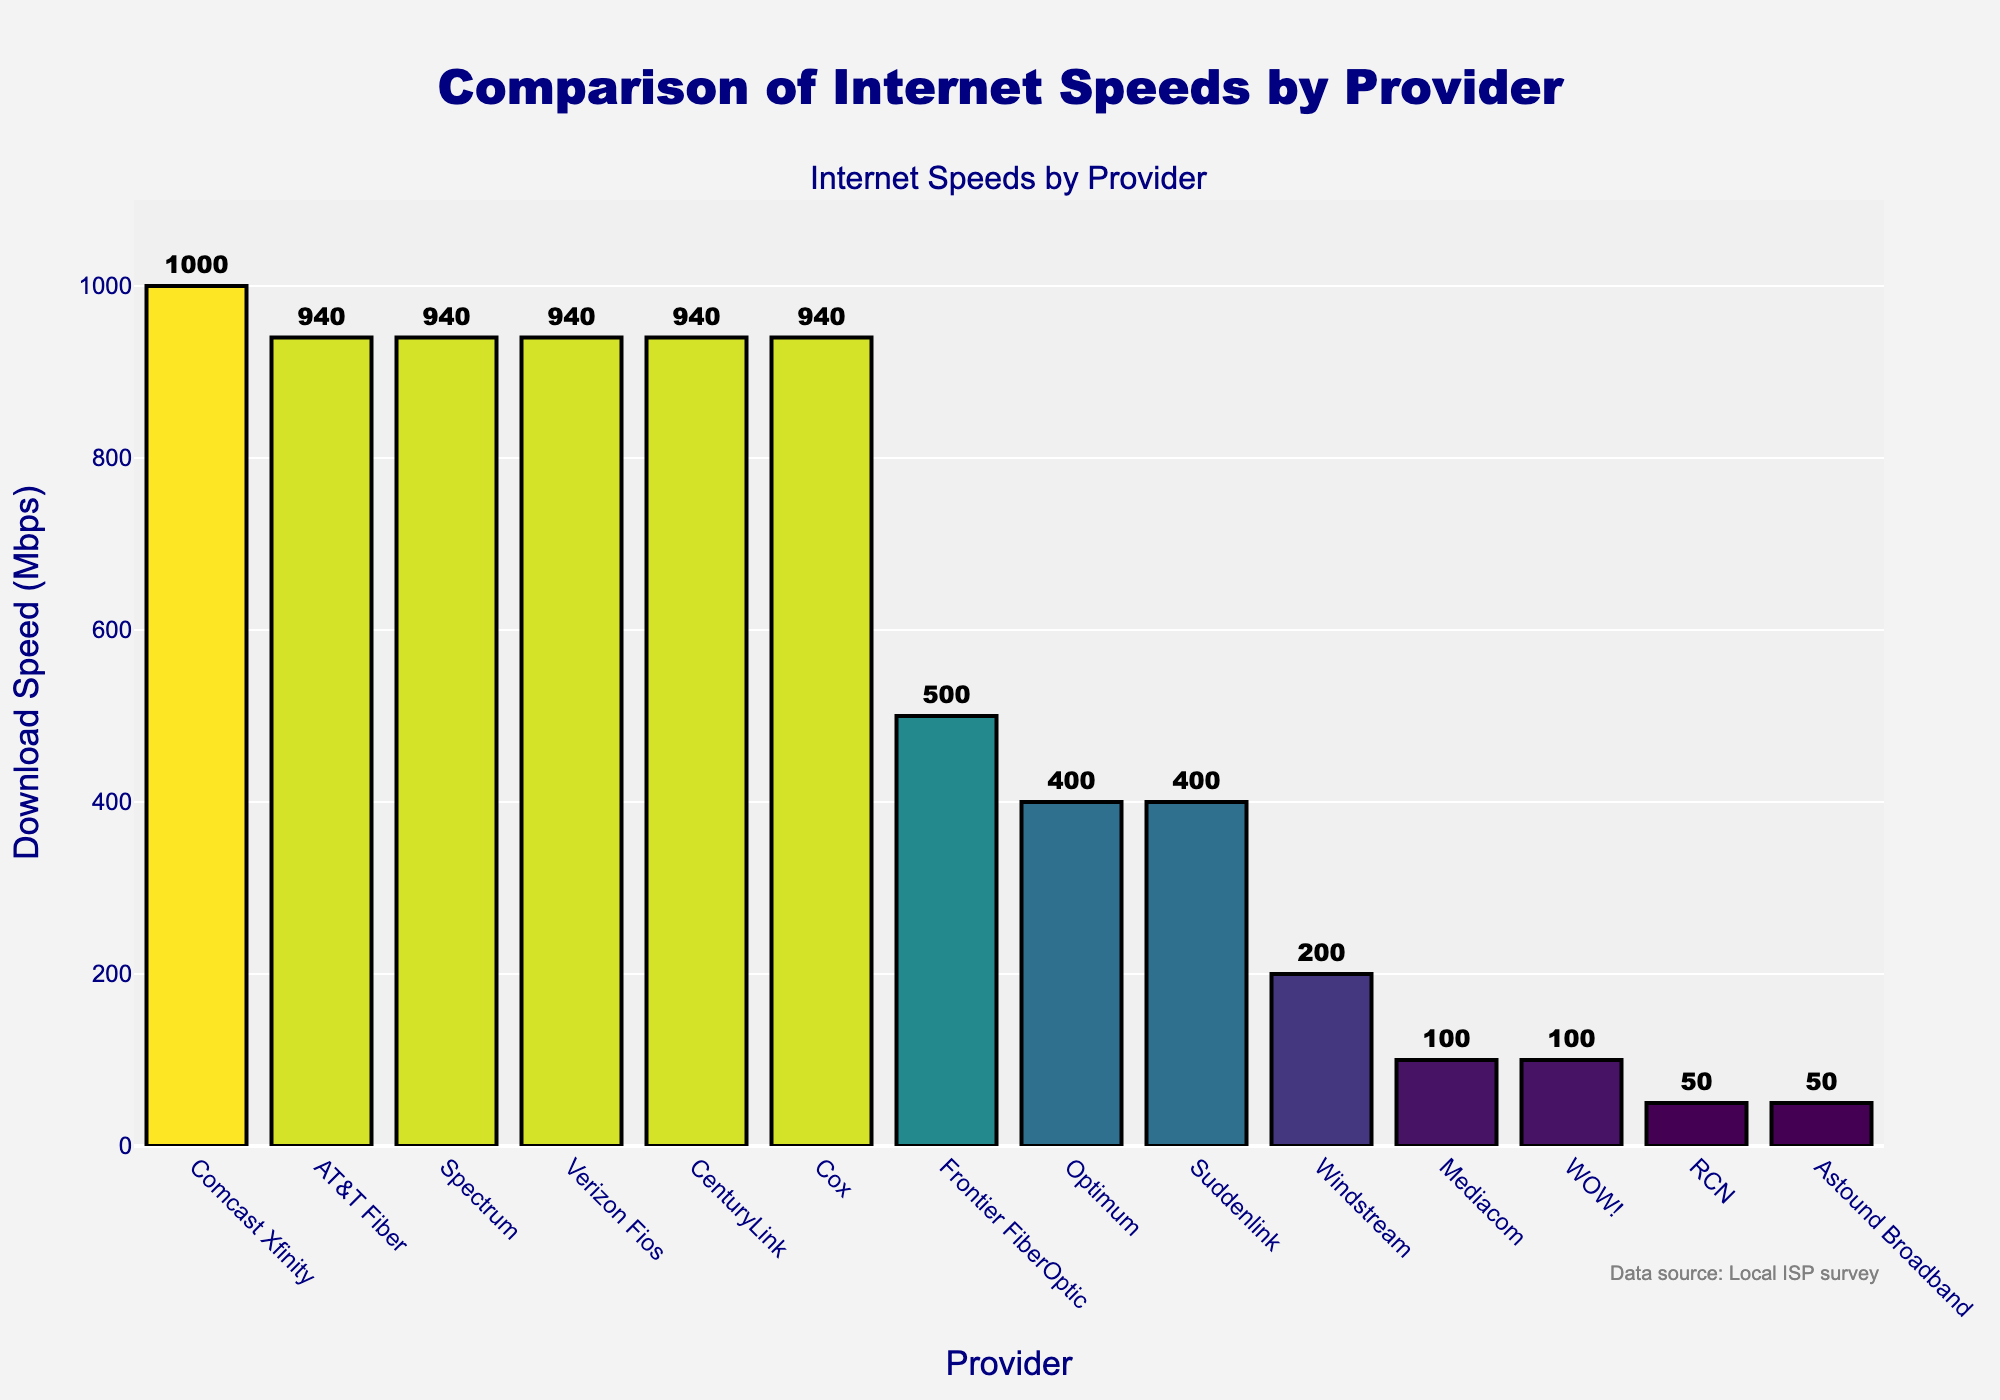What is the maximum download speed offered by any provider? The highest bar represents the maximum download speed, which is Comcast Xfinity with 1000 Mbps.
Answer: 1000 Mbps Which providers offer the same download speed of 940 Mbps? By inspecting the bars of the same height, AT&T Fiber, Spectrum, Verizon Fios, CenturyLink, and Cox all offer 940 Mbps.
Answer: AT&T Fiber, Spectrum, Verizon Fios, CenturyLink, Cox What is the difference in download speed between Comcast Xfinity and WOW!? Find the bars for Comcast Xfinity (1000 Mbps) and WOW! (100 Mbps), then subtract the latter from the former. 1000 - 100 = 900 Mbps.
Answer: 900 Mbps How many providers offer more than 500 Mbps download speed? Count the bars that exceed 500 Mbps: Comcast Xfinity, AT&T Fiber, Spectrum, Verizon Fios, CenturyLink, and Cox. There are 6 such providers.
Answer: 6 providers Which provider has the lowest download speed, and what is it? The shortest bar represents the lowest value, which is shared by RCN and Astound Broadband at 50 Mbps.
Answer: RCN, Astound Broadband, 50 Mbps What is the average download speed offered by the listed providers? Sum all the speeds and divide by the number of providers: (1000+940+940+940+940+940+500+400+400+200+100+100+50+50)/14 = 6280/14 = 448.57 Mbps.
Answer: 448.57 Mbps Which provider offers the second highest download speed and how much is it? After Comcast Xfinity (1000 Mbps), which is the highest, the next bars of the same height (940 Mbps) belong to AT&T Fiber, Spectrum, Verizon Fios, CenturyLink, and Cox.
Answer: AT&T Fiber, Spectrum, Verizon Fios, CenturyLink, Cox, 940 Mbps What is the total download speed provided by Optimum and Windstream? Add the values of Optimum (400 Mbps) and Windstream (200 Mbps): 400 + 200 = 600 Mbps.
Answer: 600 Mbps Arrange the providers in decreasing order of the download speed they offer. List the providers from highest to lowest according to the bar heights: Comcast Xfinity, AT&T Fiber, Spectrum, Verizon Fios, CenturyLink, Cox, Frontier FiberOptic, Optimum, Suddenlink, Windstream, Mediacom, WOW!, RCN, Astound Broadband.
Answer: Comcast Xfinity, AT&T Fiber, Spectrum, Verizon Fios, CenturyLink, Cox, Frontier FiberOptic, Optimum, Suddenlink, Windstream, Mediacom, WOW!, RCN, Astound Broadband Is there any provider offering exactly 200 Mbps download speed? Look for a bar representing 200 Mbps, which corresponds to Windstream.
Answer: Windstream 